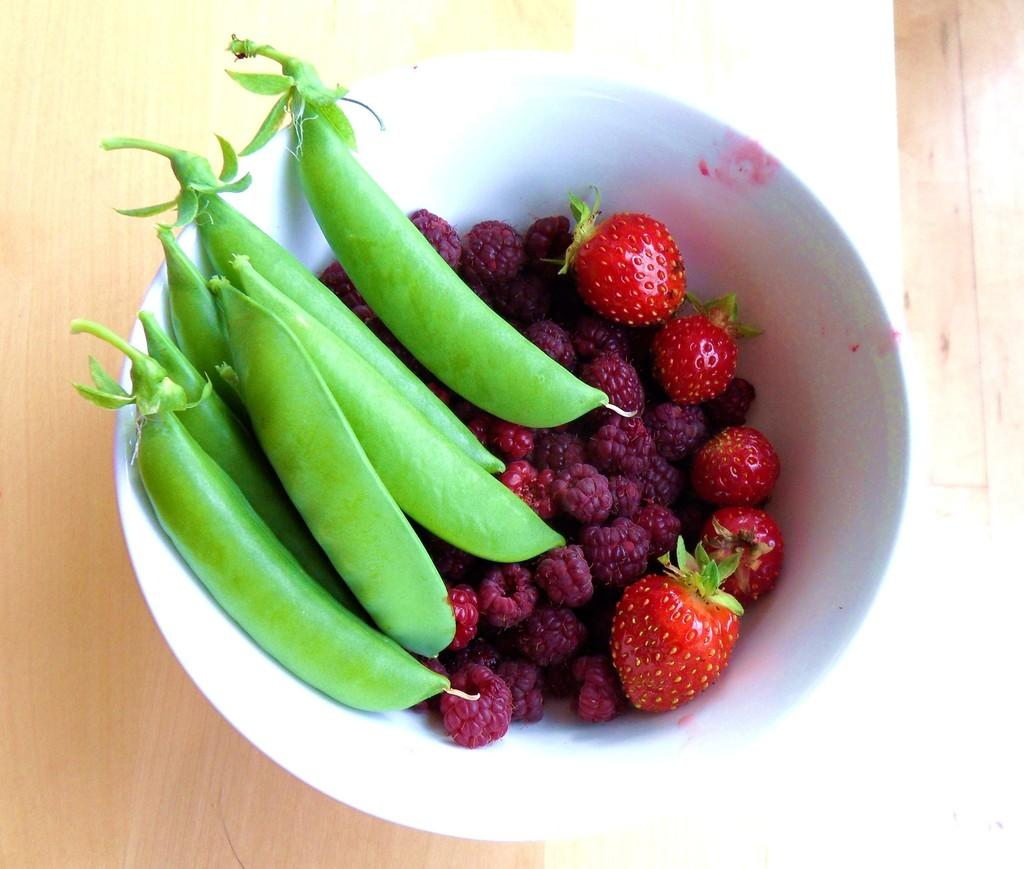What is the main object in the foreground of the image? There is a bowl in the foreground of the image. What is inside the bowl? The bowl contains beans, raspberries, and strawberries. What is the surface on which the bowl is placed? The bowl is placed on a wooden surface. What type of sink is visible in the image? There is no sink present in the image. Can you tell me if the beans in the bowl have received approval from a regulatory agency? The image does not provide any information about the approval status of the beans or any other items in the bowl. 